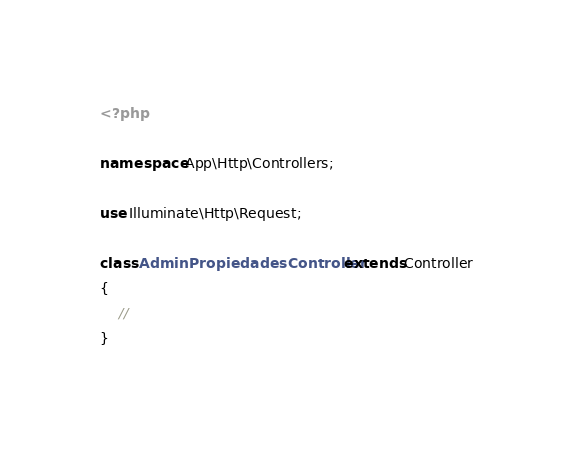Convert code to text. <code><loc_0><loc_0><loc_500><loc_500><_PHP_><?php

namespace App\Http\Controllers;

use Illuminate\Http\Request;

class AdminPropiedadesController extends Controller
{
    //
}
</code> 